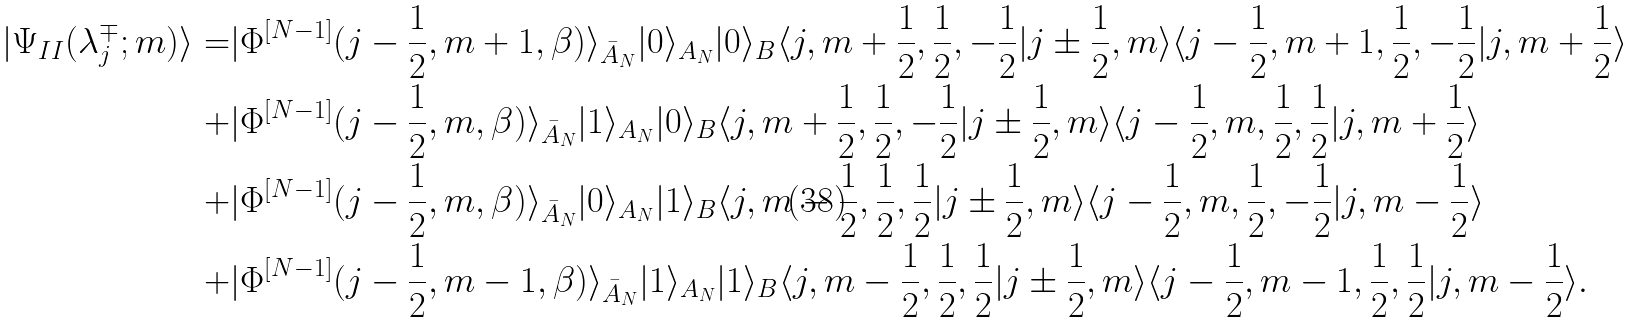Convert formula to latex. <formula><loc_0><loc_0><loc_500><loc_500>| \Psi _ { I I } ( \lambda _ { j } ^ { \mp } ; m ) \rangle = & | \Phi ^ { [ N - 1 ] } ( j - \frac { 1 } { 2 } , m + 1 , \beta ) \rangle _ { \bar { A } _ { N } } | 0 \rangle _ { A _ { N } } | 0 \rangle _ { B } \langle j , m + \frac { 1 } { 2 } , \frac { 1 } { 2 } , - \frac { 1 } { 2 } | j \pm \frac { 1 } { 2 } , m \rangle \langle j - \frac { 1 } { 2 } , m + 1 , \frac { 1 } { 2 } , - \frac { 1 } { 2 } | j , m + \frac { 1 } { 2 } \rangle \\ + & | \Phi ^ { [ N - 1 ] } ( j - \frac { 1 } { 2 } , m , \beta ) \rangle _ { \bar { A } _ { N } } | 1 \rangle _ { A _ { N } } | 0 \rangle _ { B } \langle j , m + \frac { 1 } { 2 } , \frac { 1 } { 2 } , - \frac { 1 } { 2 } | j \pm \frac { 1 } { 2 } , m \rangle \langle j - \frac { 1 } { 2 } , m , \frac { 1 } { 2 } , \frac { 1 } { 2 } | j , m + \frac { 1 } { 2 } \rangle \\ + & | \Phi ^ { [ N - 1 ] } ( j - \frac { 1 } { 2 } , m , \beta ) \rangle _ { \bar { A } _ { N } } | 0 \rangle _ { A _ { N } } | 1 \rangle _ { B } \langle j , m - \frac { 1 } { 2 } , \frac { 1 } { 2 } , \frac { 1 } { 2 } | j \pm \frac { 1 } { 2 } , m \rangle \langle j - \frac { 1 } { 2 } , m , \frac { 1 } { 2 } , - \frac { 1 } { 2 } | j , m - \frac { 1 } { 2 } \rangle \\ + & | \Phi ^ { [ N - 1 ] } ( j - \frac { 1 } { 2 } , m - 1 , \beta ) \rangle _ { \bar { A } _ { N } } | 1 \rangle _ { A _ { N } } | 1 \rangle _ { B } \langle j , m - \frac { 1 } { 2 } , \frac { 1 } { 2 } , \frac { 1 } { 2 } | j \pm \frac { 1 } { 2 } , m \rangle \langle j - \frac { 1 } { 2 } , m - 1 , \frac { 1 } { 2 } , \frac { 1 } { 2 } | j , m - \frac { 1 } { 2 } \rangle .</formula> 